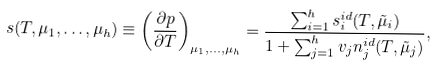<formula> <loc_0><loc_0><loc_500><loc_500>s ( T , \mu _ { 1 } , \dots , \mu _ { h } ) \equiv \left ( \frac { \partial p } { \partial T } \right ) _ { \mu _ { 1 } , \dots , \mu _ { h } } = \frac { \sum _ { i = 1 } ^ { h } s _ { i } ^ { i d } ( T , \tilde { \mu } _ { i } ) } { 1 + \sum _ { j = 1 } ^ { h } v _ { j } n _ { j } ^ { i d } ( T , \tilde { \mu } _ { j } ) } ,</formula> 